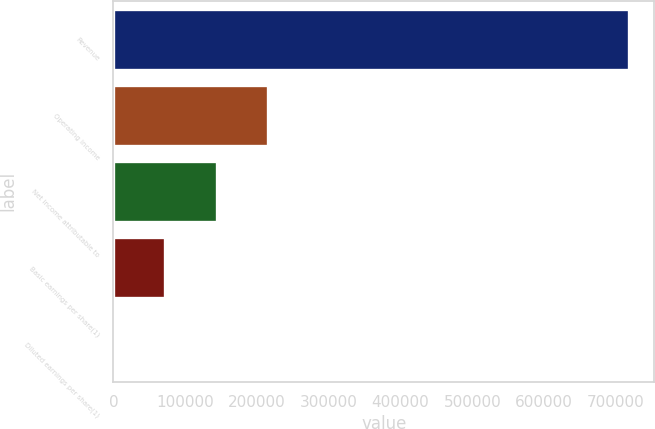Convert chart. <chart><loc_0><loc_0><loc_500><loc_500><bar_chart><fcel>Revenue<fcel>Operating income<fcel>Net income attributable to<fcel>Basic earnings per share(1)<fcel>Diluted earnings per share(1)<nl><fcel>717919<fcel>215376<fcel>143584<fcel>71792.1<fcel>0.2<nl></chart> 